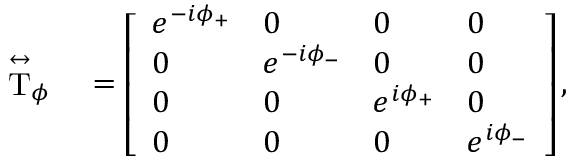<formula> <loc_0><loc_0><loc_500><loc_500>\begin{array} { r l } { \stackrel { \leftrightarrow } { T } _ { \phi } } & = \left [ \begin{array} { l l l l } { e ^ { - i \phi _ { + } } } & { 0 } & { 0 } & { 0 } \\ { 0 } & { e ^ { - i \phi _ { - } } } & { 0 } & { 0 } \\ { 0 } & { 0 } & { e ^ { i \phi _ { + } } } & { 0 } \\ { 0 } & { 0 } & { 0 } & { e ^ { i \phi _ { - } } } \end{array} \right ] , } \end{array}</formula> 